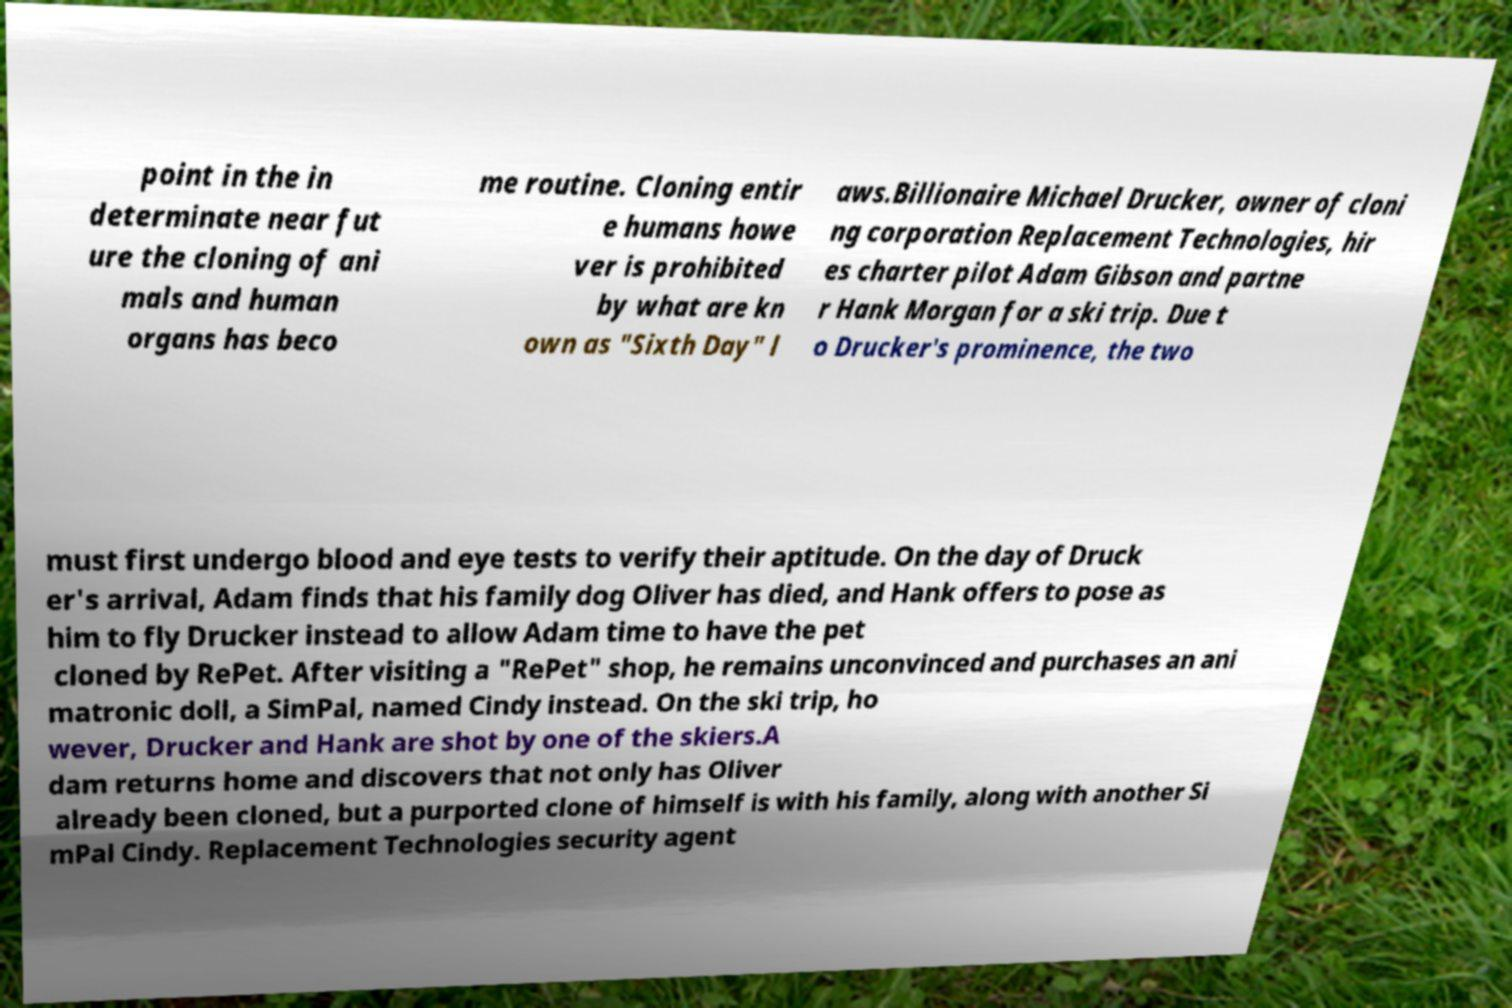What messages or text are displayed in this image? I need them in a readable, typed format. point in the in determinate near fut ure the cloning of ani mals and human organs has beco me routine. Cloning entir e humans howe ver is prohibited by what are kn own as "Sixth Day" l aws.Billionaire Michael Drucker, owner of cloni ng corporation Replacement Technologies, hir es charter pilot Adam Gibson and partne r Hank Morgan for a ski trip. Due t o Drucker's prominence, the two must first undergo blood and eye tests to verify their aptitude. On the day of Druck er's arrival, Adam finds that his family dog Oliver has died, and Hank offers to pose as him to fly Drucker instead to allow Adam time to have the pet cloned by RePet. After visiting a "RePet" shop, he remains unconvinced and purchases an ani matronic doll, a SimPal, named Cindy instead. On the ski trip, ho wever, Drucker and Hank are shot by one of the skiers.A dam returns home and discovers that not only has Oliver already been cloned, but a purported clone of himself is with his family, along with another Si mPal Cindy. Replacement Technologies security agent 